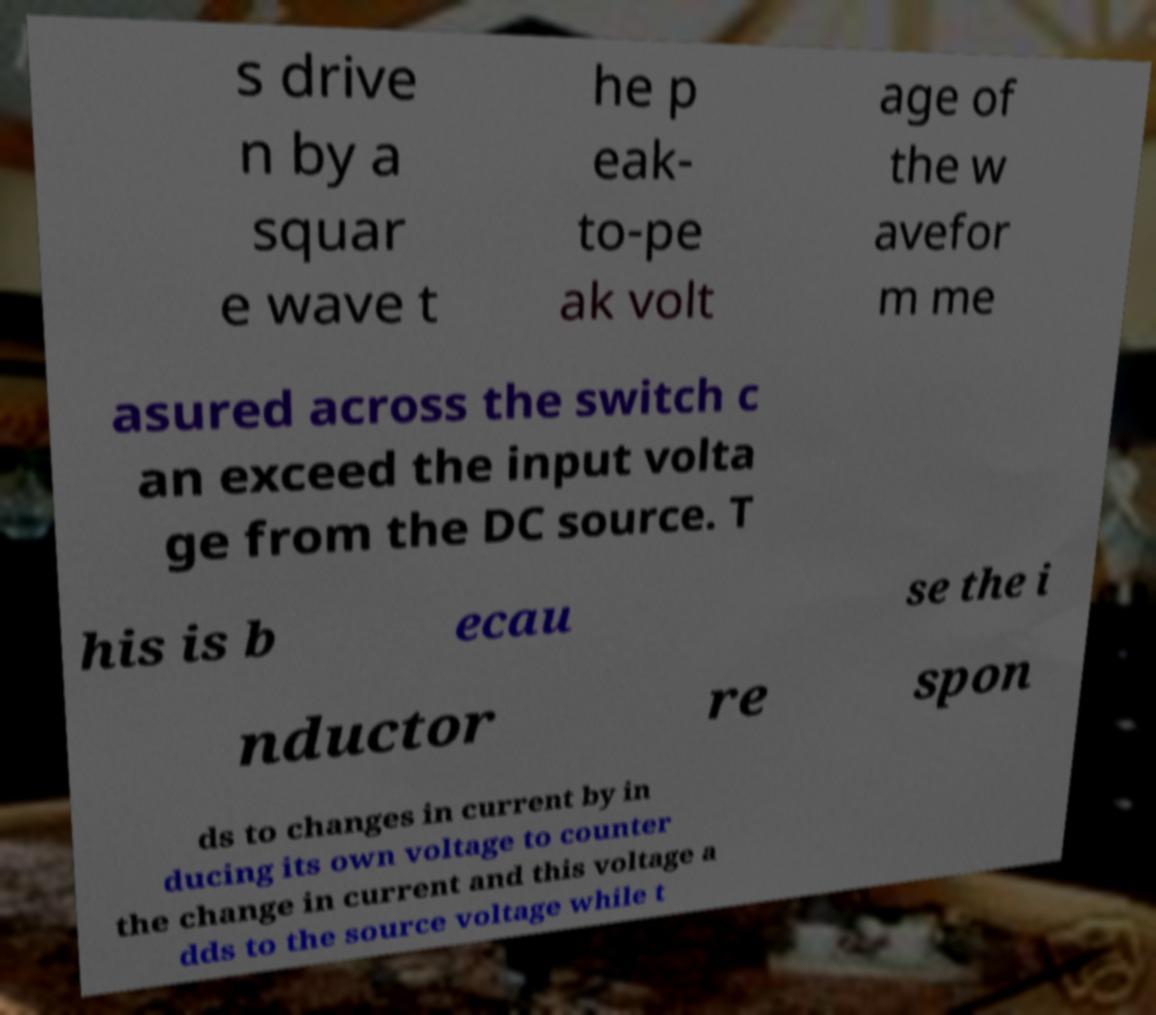Can you accurately transcribe the text from the provided image for me? s drive n by a squar e wave t he p eak- to-pe ak volt age of the w avefor m me asured across the switch c an exceed the input volta ge from the DC source. T his is b ecau se the i nductor re spon ds to changes in current by in ducing its own voltage to counter the change in current and this voltage a dds to the source voltage while t 